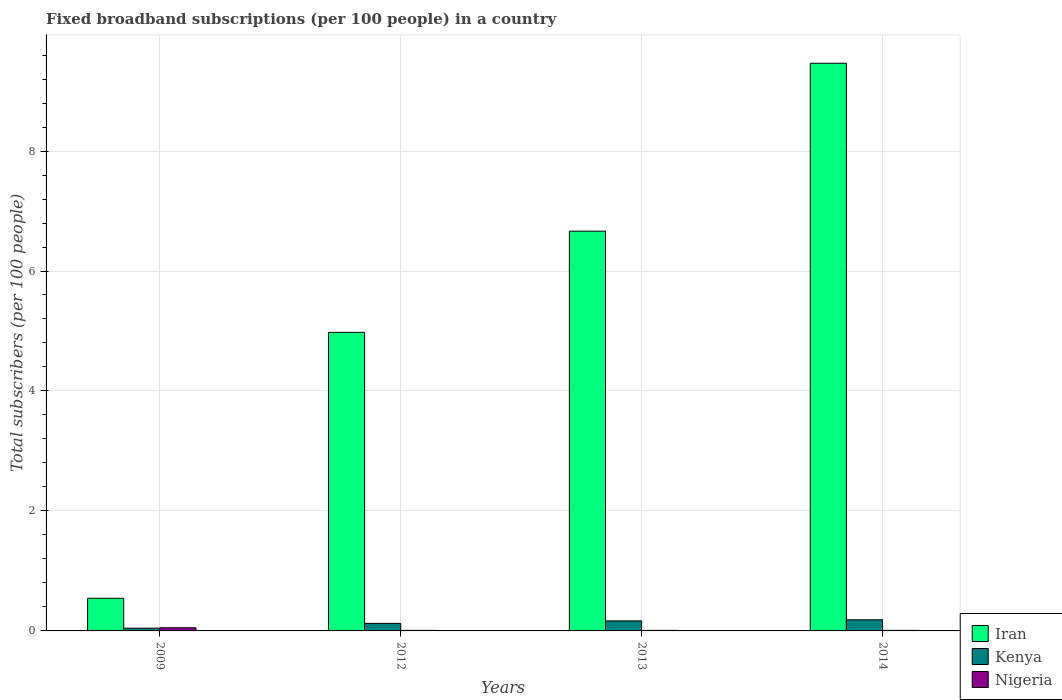How many groups of bars are there?
Make the answer very short. 4. Are the number of bars per tick equal to the number of legend labels?
Give a very brief answer. Yes. How many bars are there on the 1st tick from the left?
Your answer should be compact. 3. What is the number of broadband subscriptions in Kenya in 2014?
Provide a short and direct response. 0.19. Across all years, what is the maximum number of broadband subscriptions in Iran?
Your answer should be compact. 9.46. Across all years, what is the minimum number of broadband subscriptions in Kenya?
Make the answer very short. 0.05. What is the total number of broadband subscriptions in Kenya in the graph?
Make the answer very short. 0.52. What is the difference between the number of broadband subscriptions in Nigeria in 2012 and that in 2014?
Offer a very short reply. -0. What is the difference between the number of broadband subscriptions in Nigeria in 2012 and the number of broadband subscriptions in Kenya in 2013?
Your answer should be very brief. -0.16. What is the average number of broadband subscriptions in Kenya per year?
Provide a short and direct response. 0.13. In the year 2013, what is the difference between the number of broadband subscriptions in Nigeria and number of broadband subscriptions in Iran?
Provide a succinct answer. -6.66. In how many years, is the number of broadband subscriptions in Nigeria greater than 7.6?
Your answer should be compact. 0. What is the ratio of the number of broadband subscriptions in Iran in 2009 to that in 2013?
Give a very brief answer. 0.08. Is the difference between the number of broadband subscriptions in Nigeria in 2009 and 2012 greater than the difference between the number of broadband subscriptions in Iran in 2009 and 2012?
Provide a short and direct response. Yes. What is the difference between the highest and the second highest number of broadband subscriptions in Iran?
Keep it short and to the point. 2.8. What is the difference between the highest and the lowest number of broadband subscriptions in Kenya?
Provide a succinct answer. 0.14. What does the 1st bar from the left in 2012 represents?
Ensure brevity in your answer.  Iran. What does the 2nd bar from the right in 2013 represents?
Keep it short and to the point. Kenya. What is the difference between two consecutive major ticks on the Y-axis?
Provide a succinct answer. 2. Are the values on the major ticks of Y-axis written in scientific E-notation?
Provide a short and direct response. No. Does the graph contain any zero values?
Your answer should be compact. No. Does the graph contain grids?
Your answer should be compact. Yes. Where does the legend appear in the graph?
Offer a terse response. Bottom right. How many legend labels are there?
Offer a terse response. 3. What is the title of the graph?
Provide a short and direct response. Fixed broadband subscriptions (per 100 people) in a country. What is the label or title of the Y-axis?
Offer a terse response. Total subscribers (per 100 people). What is the Total subscribers (per 100 people) in Iran in 2009?
Give a very brief answer. 0.54. What is the Total subscribers (per 100 people) in Kenya in 2009?
Provide a succinct answer. 0.05. What is the Total subscribers (per 100 people) of Nigeria in 2009?
Offer a very short reply. 0.05. What is the Total subscribers (per 100 people) of Iran in 2012?
Make the answer very short. 4.98. What is the Total subscribers (per 100 people) of Kenya in 2012?
Your response must be concise. 0.13. What is the Total subscribers (per 100 people) in Nigeria in 2012?
Ensure brevity in your answer.  0.01. What is the Total subscribers (per 100 people) of Iran in 2013?
Give a very brief answer. 6.66. What is the Total subscribers (per 100 people) of Kenya in 2013?
Provide a succinct answer. 0.17. What is the Total subscribers (per 100 people) of Nigeria in 2013?
Your answer should be compact. 0.01. What is the Total subscribers (per 100 people) in Iran in 2014?
Your answer should be compact. 9.46. What is the Total subscribers (per 100 people) in Kenya in 2014?
Offer a very short reply. 0.19. What is the Total subscribers (per 100 people) of Nigeria in 2014?
Your answer should be very brief. 0.01. Across all years, what is the maximum Total subscribers (per 100 people) of Iran?
Ensure brevity in your answer.  9.46. Across all years, what is the maximum Total subscribers (per 100 people) of Kenya?
Keep it short and to the point. 0.19. Across all years, what is the maximum Total subscribers (per 100 people) of Nigeria?
Offer a very short reply. 0.05. Across all years, what is the minimum Total subscribers (per 100 people) of Iran?
Provide a short and direct response. 0.54. Across all years, what is the minimum Total subscribers (per 100 people) in Kenya?
Keep it short and to the point. 0.05. Across all years, what is the minimum Total subscribers (per 100 people) of Nigeria?
Provide a succinct answer. 0.01. What is the total Total subscribers (per 100 people) in Iran in the graph?
Ensure brevity in your answer.  21.65. What is the total Total subscribers (per 100 people) in Kenya in the graph?
Offer a very short reply. 0.52. What is the total Total subscribers (per 100 people) of Nigeria in the graph?
Provide a succinct answer. 0.08. What is the difference between the Total subscribers (per 100 people) in Iran in 2009 and that in 2012?
Offer a terse response. -4.43. What is the difference between the Total subscribers (per 100 people) in Kenya in 2009 and that in 2012?
Offer a terse response. -0.08. What is the difference between the Total subscribers (per 100 people) of Nigeria in 2009 and that in 2012?
Provide a short and direct response. 0.04. What is the difference between the Total subscribers (per 100 people) in Iran in 2009 and that in 2013?
Your answer should be very brief. -6.12. What is the difference between the Total subscribers (per 100 people) in Kenya in 2009 and that in 2013?
Ensure brevity in your answer.  -0.12. What is the difference between the Total subscribers (per 100 people) of Nigeria in 2009 and that in 2013?
Provide a short and direct response. 0.04. What is the difference between the Total subscribers (per 100 people) of Iran in 2009 and that in 2014?
Make the answer very short. -8.92. What is the difference between the Total subscribers (per 100 people) of Kenya in 2009 and that in 2014?
Your answer should be compact. -0.14. What is the difference between the Total subscribers (per 100 people) in Nigeria in 2009 and that in 2014?
Your answer should be very brief. 0.04. What is the difference between the Total subscribers (per 100 people) in Iran in 2012 and that in 2013?
Give a very brief answer. -1.69. What is the difference between the Total subscribers (per 100 people) in Kenya in 2012 and that in 2013?
Provide a short and direct response. -0.04. What is the difference between the Total subscribers (per 100 people) in Nigeria in 2012 and that in 2013?
Your answer should be compact. -0. What is the difference between the Total subscribers (per 100 people) of Iran in 2012 and that in 2014?
Make the answer very short. -4.49. What is the difference between the Total subscribers (per 100 people) in Kenya in 2012 and that in 2014?
Provide a succinct answer. -0.06. What is the difference between the Total subscribers (per 100 people) of Nigeria in 2012 and that in 2014?
Give a very brief answer. -0. What is the difference between the Total subscribers (per 100 people) of Iran in 2013 and that in 2014?
Ensure brevity in your answer.  -2.8. What is the difference between the Total subscribers (per 100 people) in Kenya in 2013 and that in 2014?
Provide a short and direct response. -0.02. What is the difference between the Total subscribers (per 100 people) in Nigeria in 2013 and that in 2014?
Provide a short and direct response. -0. What is the difference between the Total subscribers (per 100 people) of Iran in 2009 and the Total subscribers (per 100 people) of Kenya in 2012?
Your response must be concise. 0.42. What is the difference between the Total subscribers (per 100 people) of Iran in 2009 and the Total subscribers (per 100 people) of Nigeria in 2012?
Give a very brief answer. 0.54. What is the difference between the Total subscribers (per 100 people) of Kenya in 2009 and the Total subscribers (per 100 people) of Nigeria in 2012?
Your answer should be compact. 0.04. What is the difference between the Total subscribers (per 100 people) of Iran in 2009 and the Total subscribers (per 100 people) of Kenya in 2013?
Keep it short and to the point. 0.38. What is the difference between the Total subscribers (per 100 people) in Iran in 2009 and the Total subscribers (per 100 people) in Nigeria in 2013?
Give a very brief answer. 0.54. What is the difference between the Total subscribers (per 100 people) of Kenya in 2009 and the Total subscribers (per 100 people) of Nigeria in 2013?
Provide a short and direct response. 0.04. What is the difference between the Total subscribers (per 100 people) in Iran in 2009 and the Total subscribers (per 100 people) in Kenya in 2014?
Give a very brief answer. 0.36. What is the difference between the Total subscribers (per 100 people) in Iran in 2009 and the Total subscribers (per 100 people) in Nigeria in 2014?
Give a very brief answer. 0.54. What is the difference between the Total subscribers (per 100 people) of Kenya in 2009 and the Total subscribers (per 100 people) of Nigeria in 2014?
Keep it short and to the point. 0.04. What is the difference between the Total subscribers (per 100 people) of Iran in 2012 and the Total subscribers (per 100 people) of Kenya in 2013?
Give a very brief answer. 4.81. What is the difference between the Total subscribers (per 100 people) of Iran in 2012 and the Total subscribers (per 100 people) of Nigeria in 2013?
Make the answer very short. 4.97. What is the difference between the Total subscribers (per 100 people) of Kenya in 2012 and the Total subscribers (per 100 people) of Nigeria in 2013?
Keep it short and to the point. 0.12. What is the difference between the Total subscribers (per 100 people) in Iran in 2012 and the Total subscribers (per 100 people) in Kenya in 2014?
Your answer should be compact. 4.79. What is the difference between the Total subscribers (per 100 people) in Iran in 2012 and the Total subscribers (per 100 people) in Nigeria in 2014?
Make the answer very short. 4.97. What is the difference between the Total subscribers (per 100 people) of Kenya in 2012 and the Total subscribers (per 100 people) of Nigeria in 2014?
Ensure brevity in your answer.  0.12. What is the difference between the Total subscribers (per 100 people) in Iran in 2013 and the Total subscribers (per 100 people) in Kenya in 2014?
Your answer should be compact. 6.48. What is the difference between the Total subscribers (per 100 people) in Iran in 2013 and the Total subscribers (per 100 people) in Nigeria in 2014?
Your response must be concise. 6.66. What is the difference between the Total subscribers (per 100 people) in Kenya in 2013 and the Total subscribers (per 100 people) in Nigeria in 2014?
Your answer should be very brief. 0.16. What is the average Total subscribers (per 100 people) in Iran per year?
Give a very brief answer. 5.41. What is the average Total subscribers (per 100 people) in Kenya per year?
Provide a succinct answer. 0.13. What is the average Total subscribers (per 100 people) of Nigeria per year?
Give a very brief answer. 0.02. In the year 2009, what is the difference between the Total subscribers (per 100 people) in Iran and Total subscribers (per 100 people) in Kenya?
Give a very brief answer. 0.5. In the year 2009, what is the difference between the Total subscribers (per 100 people) of Iran and Total subscribers (per 100 people) of Nigeria?
Give a very brief answer. 0.49. In the year 2009, what is the difference between the Total subscribers (per 100 people) of Kenya and Total subscribers (per 100 people) of Nigeria?
Your response must be concise. -0.01. In the year 2012, what is the difference between the Total subscribers (per 100 people) of Iran and Total subscribers (per 100 people) of Kenya?
Your answer should be compact. 4.85. In the year 2012, what is the difference between the Total subscribers (per 100 people) of Iran and Total subscribers (per 100 people) of Nigeria?
Your answer should be compact. 4.97. In the year 2012, what is the difference between the Total subscribers (per 100 people) of Kenya and Total subscribers (per 100 people) of Nigeria?
Make the answer very short. 0.12. In the year 2013, what is the difference between the Total subscribers (per 100 people) in Iran and Total subscribers (per 100 people) in Kenya?
Provide a short and direct response. 6.5. In the year 2013, what is the difference between the Total subscribers (per 100 people) of Iran and Total subscribers (per 100 people) of Nigeria?
Ensure brevity in your answer.  6.66. In the year 2013, what is the difference between the Total subscribers (per 100 people) of Kenya and Total subscribers (per 100 people) of Nigeria?
Offer a terse response. 0.16. In the year 2014, what is the difference between the Total subscribers (per 100 people) in Iran and Total subscribers (per 100 people) in Kenya?
Ensure brevity in your answer.  9.28. In the year 2014, what is the difference between the Total subscribers (per 100 people) in Iran and Total subscribers (per 100 people) in Nigeria?
Offer a terse response. 9.45. In the year 2014, what is the difference between the Total subscribers (per 100 people) in Kenya and Total subscribers (per 100 people) in Nigeria?
Keep it short and to the point. 0.18. What is the ratio of the Total subscribers (per 100 people) of Iran in 2009 to that in 2012?
Give a very brief answer. 0.11. What is the ratio of the Total subscribers (per 100 people) in Kenya in 2009 to that in 2012?
Your answer should be very brief. 0.36. What is the ratio of the Total subscribers (per 100 people) in Nigeria in 2009 to that in 2012?
Ensure brevity in your answer.  6.24. What is the ratio of the Total subscribers (per 100 people) in Iran in 2009 to that in 2013?
Your answer should be very brief. 0.08. What is the ratio of the Total subscribers (per 100 people) in Kenya in 2009 to that in 2013?
Provide a short and direct response. 0.27. What is the ratio of the Total subscribers (per 100 people) of Nigeria in 2009 to that in 2013?
Make the answer very short. 6.09. What is the ratio of the Total subscribers (per 100 people) of Iran in 2009 to that in 2014?
Provide a short and direct response. 0.06. What is the ratio of the Total subscribers (per 100 people) in Kenya in 2009 to that in 2014?
Ensure brevity in your answer.  0.25. What is the ratio of the Total subscribers (per 100 people) of Nigeria in 2009 to that in 2014?
Provide a short and direct response. 5.98. What is the ratio of the Total subscribers (per 100 people) in Iran in 2012 to that in 2013?
Make the answer very short. 0.75. What is the ratio of the Total subscribers (per 100 people) of Kenya in 2012 to that in 2013?
Provide a short and direct response. 0.75. What is the ratio of the Total subscribers (per 100 people) of Nigeria in 2012 to that in 2013?
Offer a very short reply. 0.98. What is the ratio of the Total subscribers (per 100 people) of Iran in 2012 to that in 2014?
Keep it short and to the point. 0.53. What is the ratio of the Total subscribers (per 100 people) of Kenya in 2012 to that in 2014?
Offer a terse response. 0.68. What is the ratio of the Total subscribers (per 100 people) in Nigeria in 2012 to that in 2014?
Keep it short and to the point. 0.96. What is the ratio of the Total subscribers (per 100 people) of Iran in 2013 to that in 2014?
Make the answer very short. 0.7. What is the ratio of the Total subscribers (per 100 people) in Kenya in 2013 to that in 2014?
Keep it short and to the point. 0.9. What is the ratio of the Total subscribers (per 100 people) in Nigeria in 2013 to that in 2014?
Offer a terse response. 0.98. What is the difference between the highest and the second highest Total subscribers (per 100 people) in Iran?
Provide a short and direct response. 2.8. What is the difference between the highest and the second highest Total subscribers (per 100 people) in Kenya?
Provide a succinct answer. 0.02. What is the difference between the highest and the second highest Total subscribers (per 100 people) in Nigeria?
Make the answer very short. 0.04. What is the difference between the highest and the lowest Total subscribers (per 100 people) of Iran?
Make the answer very short. 8.92. What is the difference between the highest and the lowest Total subscribers (per 100 people) in Kenya?
Make the answer very short. 0.14. What is the difference between the highest and the lowest Total subscribers (per 100 people) in Nigeria?
Make the answer very short. 0.04. 